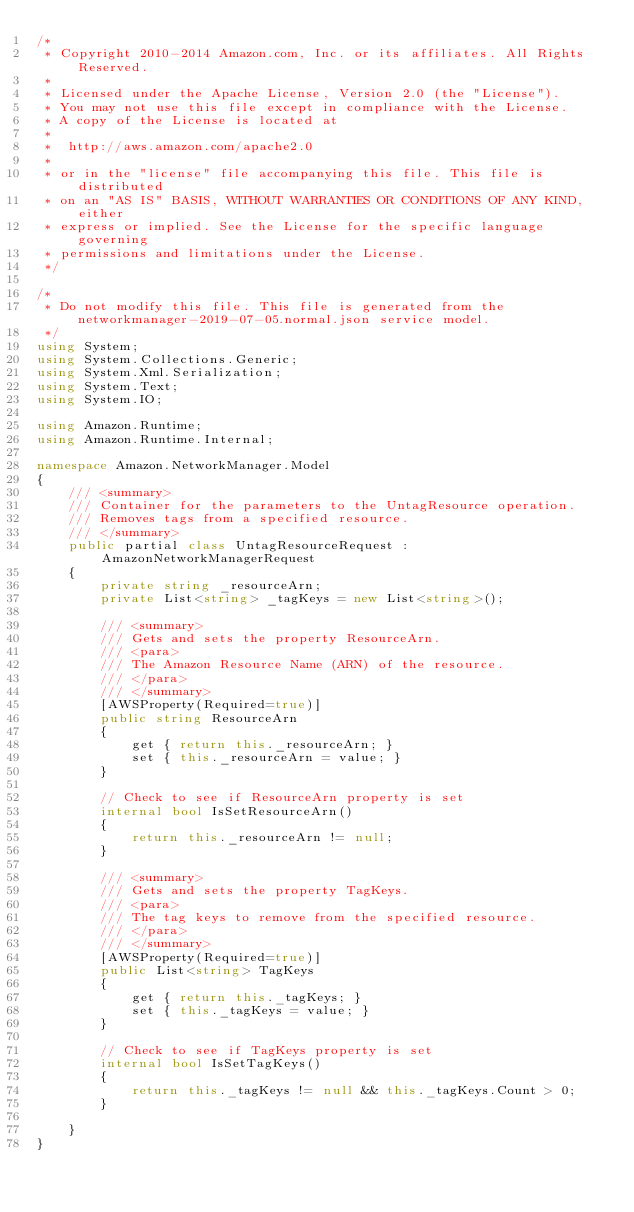<code> <loc_0><loc_0><loc_500><loc_500><_C#_>/*
 * Copyright 2010-2014 Amazon.com, Inc. or its affiliates. All Rights Reserved.
 * 
 * Licensed under the Apache License, Version 2.0 (the "License").
 * You may not use this file except in compliance with the License.
 * A copy of the License is located at
 * 
 *  http://aws.amazon.com/apache2.0
 * 
 * or in the "license" file accompanying this file. This file is distributed
 * on an "AS IS" BASIS, WITHOUT WARRANTIES OR CONDITIONS OF ANY KIND, either
 * express or implied. See the License for the specific language governing
 * permissions and limitations under the License.
 */

/*
 * Do not modify this file. This file is generated from the networkmanager-2019-07-05.normal.json service model.
 */
using System;
using System.Collections.Generic;
using System.Xml.Serialization;
using System.Text;
using System.IO;

using Amazon.Runtime;
using Amazon.Runtime.Internal;

namespace Amazon.NetworkManager.Model
{
    /// <summary>
    /// Container for the parameters to the UntagResource operation.
    /// Removes tags from a specified resource.
    /// </summary>
    public partial class UntagResourceRequest : AmazonNetworkManagerRequest
    {
        private string _resourceArn;
        private List<string> _tagKeys = new List<string>();

        /// <summary>
        /// Gets and sets the property ResourceArn. 
        /// <para>
        /// The Amazon Resource Name (ARN) of the resource.
        /// </para>
        /// </summary>
        [AWSProperty(Required=true)]
        public string ResourceArn
        {
            get { return this._resourceArn; }
            set { this._resourceArn = value; }
        }

        // Check to see if ResourceArn property is set
        internal bool IsSetResourceArn()
        {
            return this._resourceArn != null;
        }

        /// <summary>
        /// Gets and sets the property TagKeys. 
        /// <para>
        /// The tag keys to remove from the specified resource.
        /// </para>
        /// </summary>
        [AWSProperty(Required=true)]
        public List<string> TagKeys
        {
            get { return this._tagKeys; }
            set { this._tagKeys = value; }
        }

        // Check to see if TagKeys property is set
        internal bool IsSetTagKeys()
        {
            return this._tagKeys != null && this._tagKeys.Count > 0; 
        }

    }
}</code> 